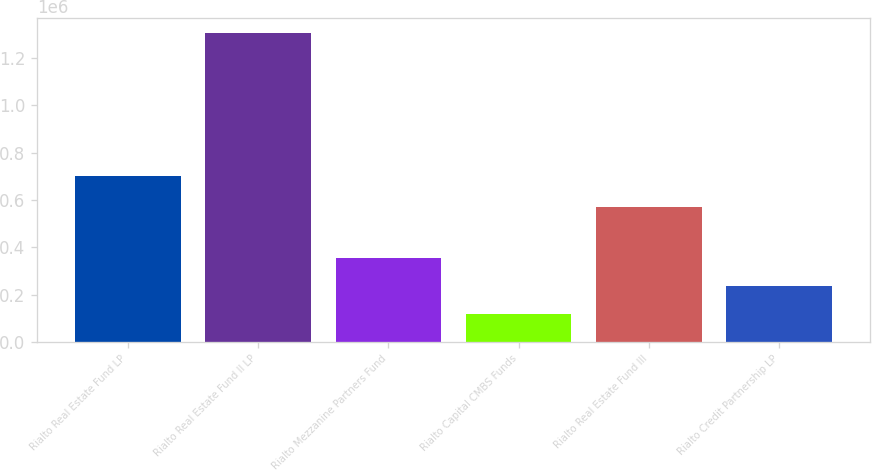<chart> <loc_0><loc_0><loc_500><loc_500><bar_chart><fcel>Rialto Real Estate Fund LP<fcel>Rialto Real Estate Fund II LP<fcel>Rialto Mezzanine Partners Fund<fcel>Rialto Capital CMBS Funds<fcel>Rialto Real Estate Fund III<fcel>Rialto Credit Partnership LP<nl><fcel>700006<fcel>1.305e+06<fcel>356339<fcel>119174<fcel>569482<fcel>237757<nl></chart> 